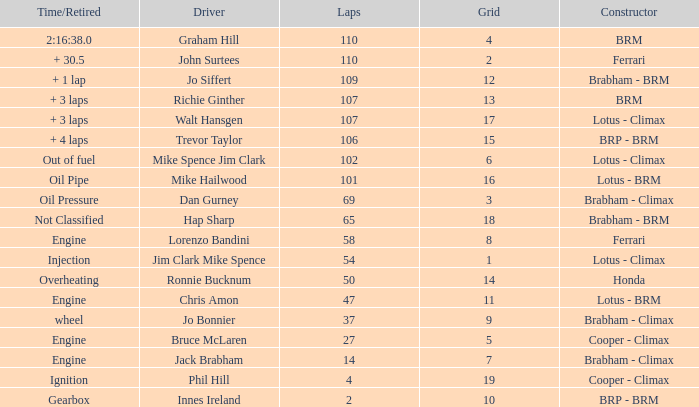What time/retired for grid 18? Not Classified. 